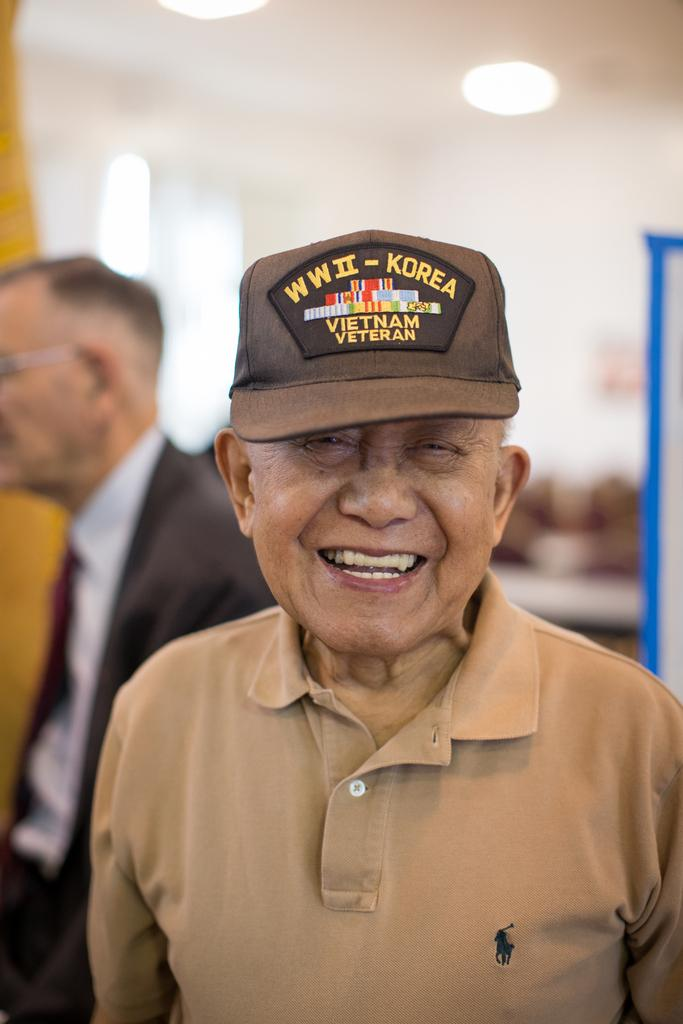What is the main subject of the image? The main subject of the image is a man. What is the man doing in the image? The man is smiling in the image. Can you describe the presence of another person in the image? Yes, there is another person in the image. What is the condition of the background in the image? The background of the image is blurred. What type of pig can be seen wearing a necklace in the image? There is no pig or necklace present in the image. What type of pan is visible in the man's hand in the image? There is no pan visible in the man's hand or anywhere in the image. 